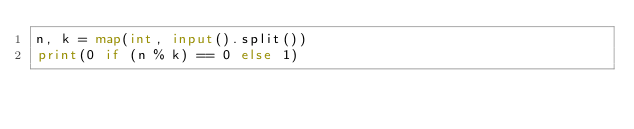Convert code to text. <code><loc_0><loc_0><loc_500><loc_500><_Python_>n, k = map(int, input().split())
print(0 if (n % k) == 0 else 1)</code> 